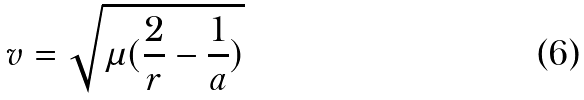Convert formula to latex. <formula><loc_0><loc_0><loc_500><loc_500>v = \sqrt { \mu ( \frac { 2 } { r } - \frac { 1 } { a } ) }</formula> 